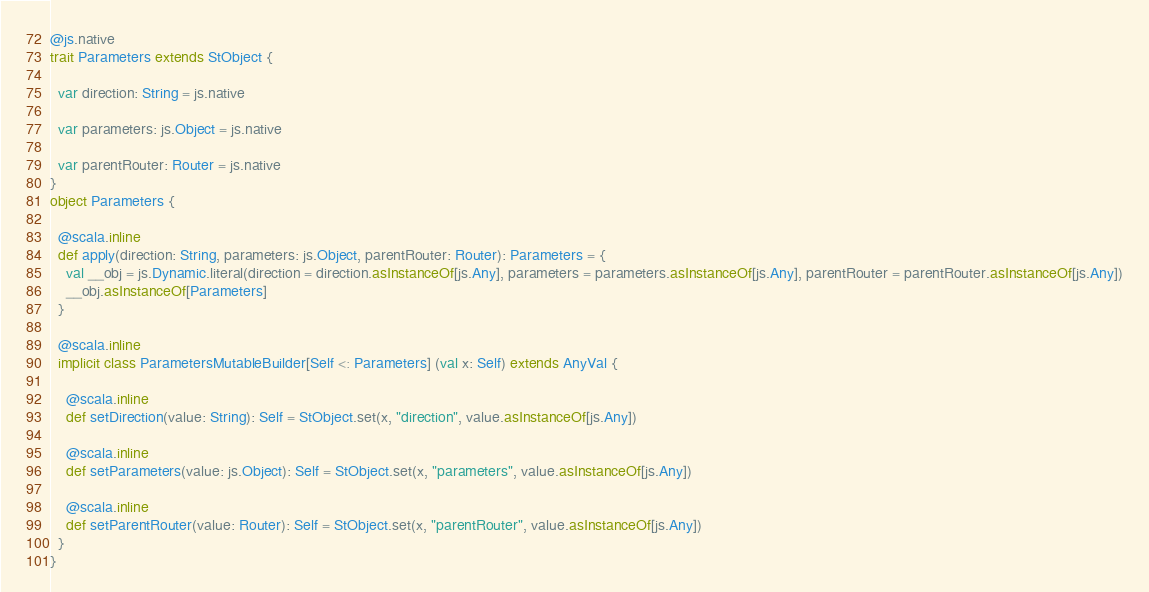<code> <loc_0><loc_0><loc_500><loc_500><_Scala_>
@js.native
trait Parameters extends StObject {
  
  var direction: String = js.native
  
  var parameters: js.Object = js.native
  
  var parentRouter: Router = js.native
}
object Parameters {
  
  @scala.inline
  def apply(direction: String, parameters: js.Object, parentRouter: Router): Parameters = {
    val __obj = js.Dynamic.literal(direction = direction.asInstanceOf[js.Any], parameters = parameters.asInstanceOf[js.Any], parentRouter = parentRouter.asInstanceOf[js.Any])
    __obj.asInstanceOf[Parameters]
  }
  
  @scala.inline
  implicit class ParametersMutableBuilder[Self <: Parameters] (val x: Self) extends AnyVal {
    
    @scala.inline
    def setDirection(value: String): Self = StObject.set(x, "direction", value.asInstanceOf[js.Any])
    
    @scala.inline
    def setParameters(value: js.Object): Self = StObject.set(x, "parameters", value.asInstanceOf[js.Any])
    
    @scala.inline
    def setParentRouter(value: Router): Self = StObject.set(x, "parentRouter", value.asInstanceOf[js.Any])
  }
}
</code> 